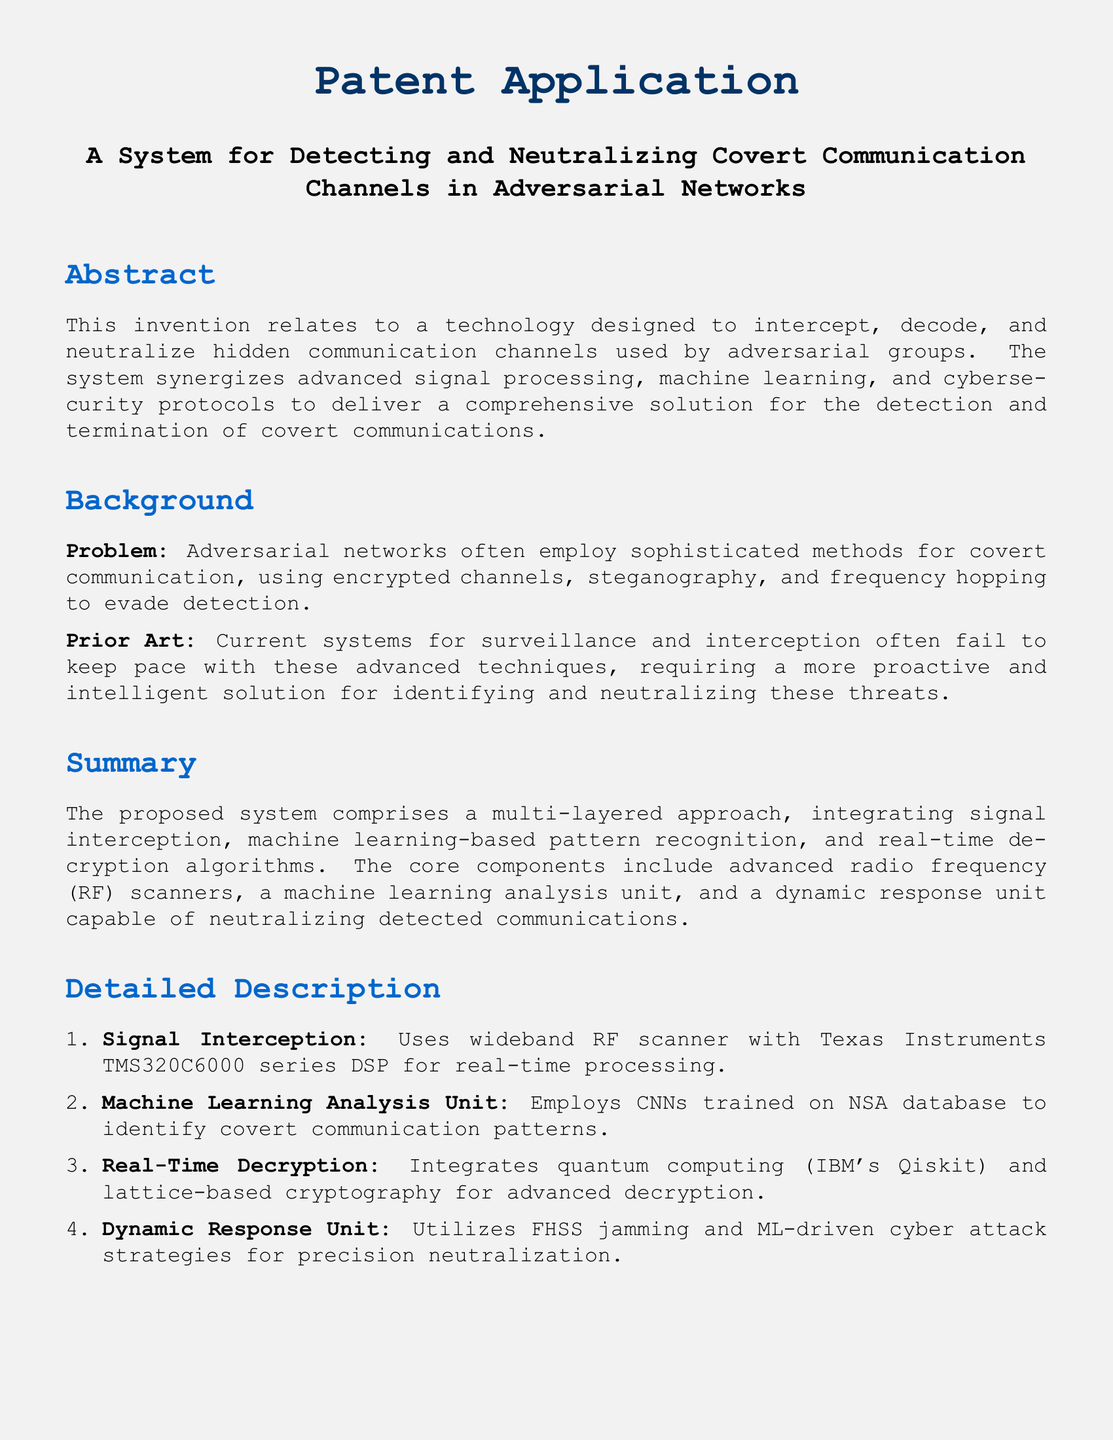What is the title of the patent? The title is explicitly stated in the document's header section, detailing the focus of the invention.
Answer: A System for Detecting and Neutralizing Covert Communication Channels in Adversarial Networks What technology does the system use for real-time processing? This information specifies the technology implemented for processing signals in real time within the system.
Answer: Texas Instruments TMS320C6000 series DSP Which machine learning structure is used for analysis? The document highlights the specific type of neural network employed in the machine learning analysis unit.
Answer: Convolutional Neural Networks What integration technology is mentioned for real-time decryption? The document indicates a specific platform that supports the decryption processes described in the invention.
Answer: IBM's Qiskit What is the purpose of the dynamic response unit? The text outlines the primary function of this component in the context of neutralizing detected communications.
Answer: Precision neutralization How many claims are listed in the patent application? The claims section indicates the total number of distinct claims made regarding the system.
Answer: Five What type of communication methods does the system aim to detect? The background of the document explains the specific communication tactics used by adversarial networks that the system targets.
Answer: Covert communication channels Which two technologies are mentioned for neutralization? This question asks for the specific technologies indicated in the claims for addressing the detected communications.
Answer: FHSS jamming and machine learning-driven cyber attack strategies What is the primary benefit of the described system? The conclusion of the document encapsulates the main advantage offered by the invention to national security.
Answer: Enhancing national security and intelligence capabilities 